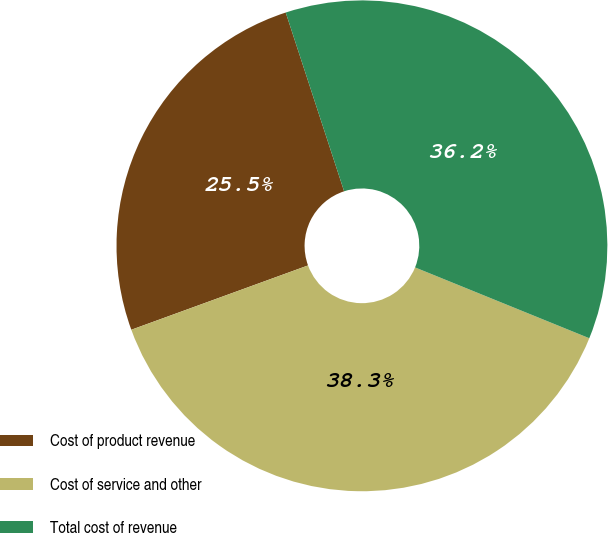Convert chart to OTSL. <chart><loc_0><loc_0><loc_500><loc_500><pie_chart><fcel>Cost of product revenue<fcel>Cost of service and other<fcel>Total cost of revenue<nl><fcel>25.53%<fcel>38.3%<fcel>36.17%<nl></chart> 